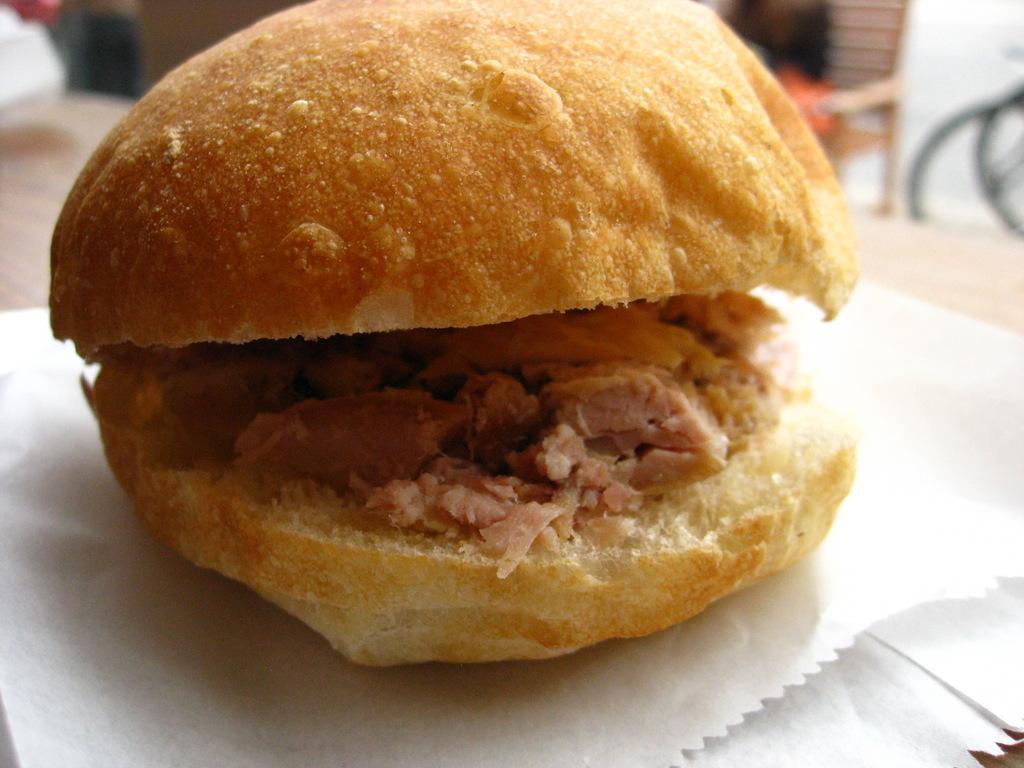What type of food is visible in the image? There is a burger in the image. How is the burger contained or covered in the image? The burger is on a paper cover. Where is the paper cover with the burger placed? The paper cover with the burger is placed on a table. What type of plant is growing on the ship in the image? There is no ship or plant present in the image; it features a burger on a paper cover placed on a table. 